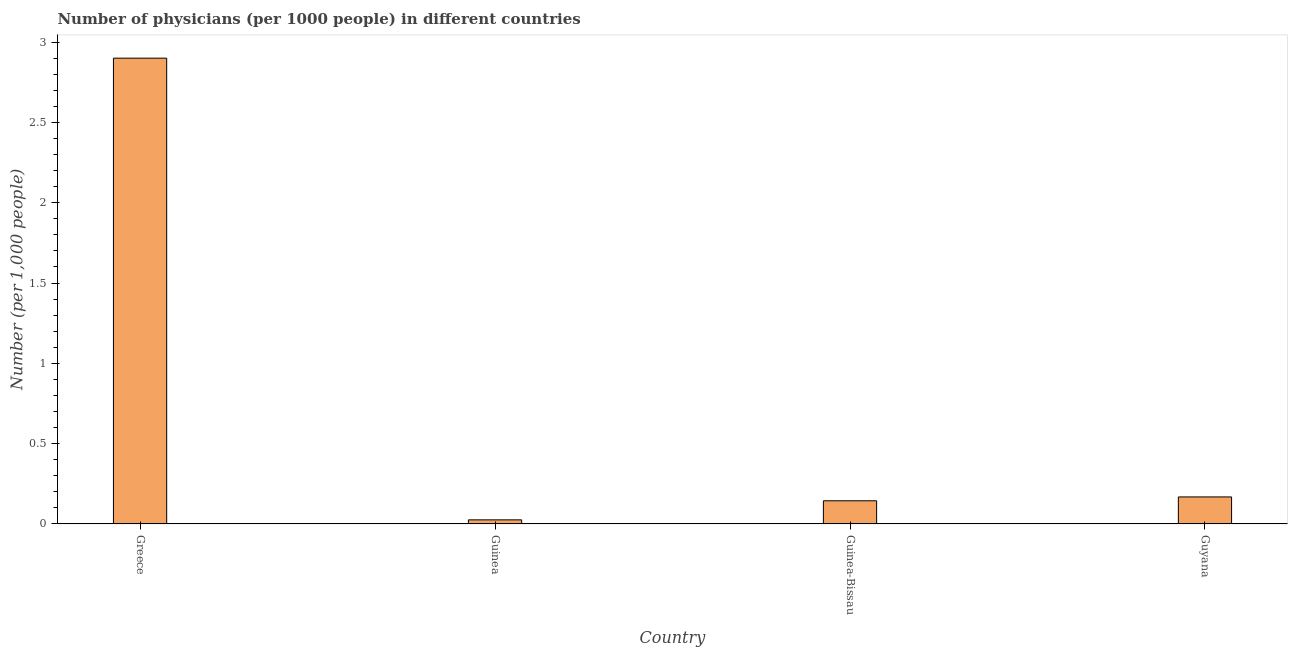Does the graph contain grids?
Give a very brief answer. No. What is the title of the graph?
Offer a very short reply. Number of physicians (per 1000 people) in different countries. What is the label or title of the X-axis?
Your answer should be very brief. Country. What is the label or title of the Y-axis?
Give a very brief answer. Number (per 1,0 people). What is the number of physicians in Guinea-Bissau?
Your response must be concise. 0.14. Across all countries, what is the minimum number of physicians?
Your response must be concise. 0.03. In which country was the number of physicians minimum?
Your answer should be compact. Guinea. What is the sum of the number of physicians?
Offer a very short reply. 3.24. What is the difference between the number of physicians in Greece and Guinea-Bissau?
Provide a succinct answer. 2.76. What is the average number of physicians per country?
Your answer should be very brief. 0.81. What is the median number of physicians?
Give a very brief answer. 0.16. What is the ratio of the number of physicians in Guinea to that in Guyana?
Provide a succinct answer. 0.15. Is the difference between the number of physicians in Guinea-Bissau and Guyana greater than the difference between any two countries?
Offer a very short reply. No. What is the difference between the highest and the second highest number of physicians?
Make the answer very short. 2.73. What is the difference between the highest and the lowest number of physicians?
Your answer should be very brief. 2.87. In how many countries, is the number of physicians greater than the average number of physicians taken over all countries?
Make the answer very short. 1. Are all the bars in the graph horizontal?
Keep it short and to the point. No. How many countries are there in the graph?
Ensure brevity in your answer.  4. What is the difference between two consecutive major ticks on the Y-axis?
Give a very brief answer. 0.5. Are the values on the major ticks of Y-axis written in scientific E-notation?
Provide a succinct answer. No. What is the Number (per 1,000 people) in Greece?
Provide a short and direct response. 2.9. What is the Number (per 1,000 people) of Guinea?
Keep it short and to the point. 0.03. What is the Number (per 1,000 people) of Guinea-Bissau?
Keep it short and to the point. 0.14. What is the Number (per 1,000 people) of Guyana?
Your response must be concise. 0.17. What is the difference between the Number (per 1,000 people) in Greece and Guinea?
Give a very brief answer. 2.87. What is the difference between the Number (per 1,000 people) in Greece and Guinea-Bissau?
Ensure brevity in your answer.  2.76. What is the difference between the Number (per 1,000 people) in Greece and Guyana?
Your answer should be compact. 2.73. What is the difference between the Number (per 1,000 people) in Guinea and Guinea-Bissau?
Make the answer very short. -0.12. What is the difference between the Number (per 1,000 people) in Guinea and Guyana?
Offer a terse response. -0.14. What is the difference between the Number (per 1,000 people) in Guinea-Bissau and Guyana?
Your answer should be very brief. -0.02. What is the ratio of the Number (per 1,000 people) in Greece to that in Guinea?
Give a very brief answer. 112.84. What is the ratio of the Number (per 1,000 people) in Greece to that in Guinea-Bissau?
Your response must be concise. 20.08. What is the ratio of the Number (per 1,000 people) in Greece to that in Guyana?
Your response must be concise. 17.22. What is the ratio of the Number (per 1,000 people) in Guinea to that in Guinea-Bissau?
Your answer should be very brief. 0.18. What is the ratio of the Number (per 1,000 people) in Guinea to that in Guyana?
Ensure brevity in your answer.  0.15. What is the ratio of the Number (per 1,000 people) in Guinea-Bissau to that in Guyana?
Make the answer very short. 0.86. 